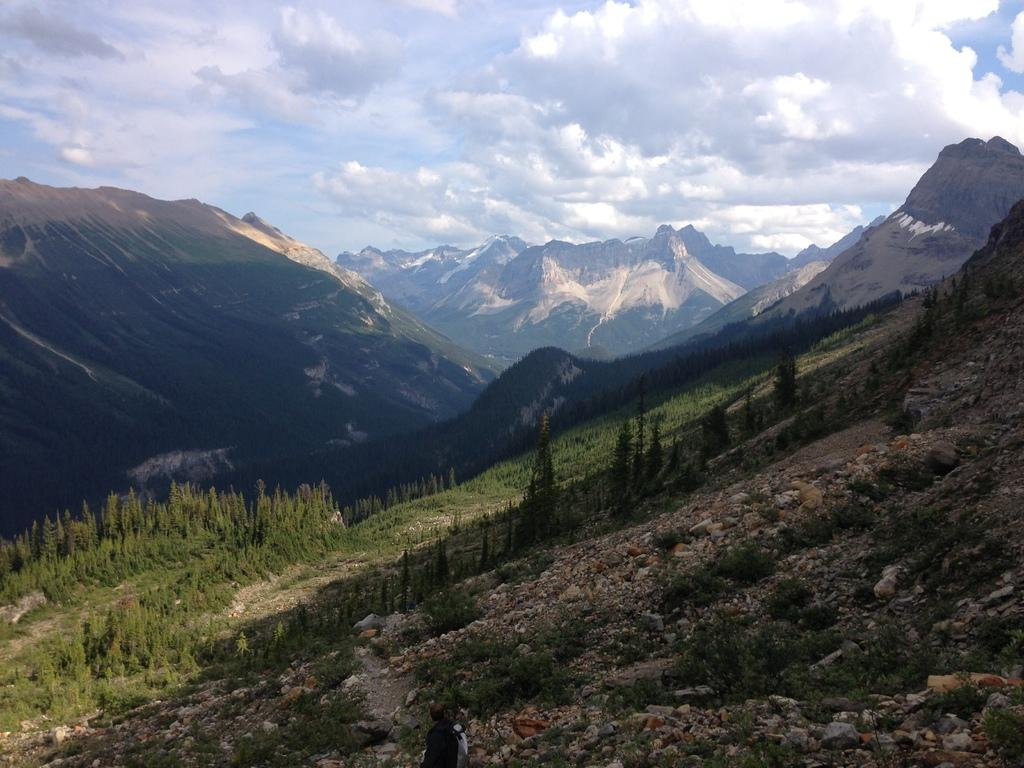What type of location is depicted in the image? The image depicts a hill station. What natural features can be seen in the image? There are mountains in the image. What is the man in the image doing? The man is walking on the first mountain. What is the terrain like where the man is walking? The man is walking between rocks. What type of trade is happening between the man and the rocks in the image? There is no trade happening between the man and the rocks in the image; the man is simply walking between them. What is the man protesting against in the image? There is no protest depicted in the image; the man is just walking between rocks on the mountain. 